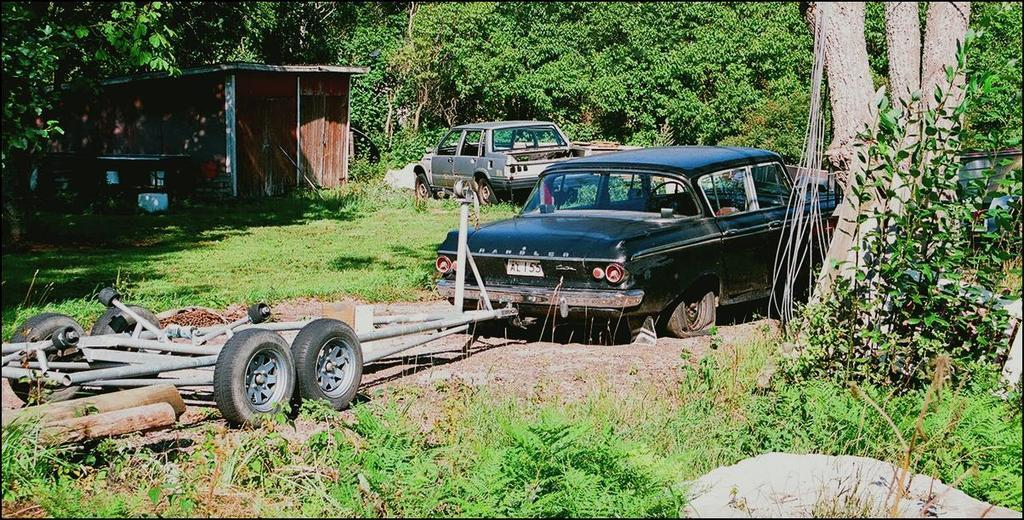What is located in the center of the image? There are vehicles in the center of the image. What type of natural elements can be seen in the image? There are trees, grass, and plants visible in the image. What objects are related to the vehicles in the image? There are tires and rods in the image. What type of structure is visible in the background of the image? There is a wooden house in the background of the image. What is the caption of the image? There is no caption present in the image. How does the income of the society depicted in the image affect the presence of the vehicles? The image does not provide any information about the society or its income, so it is not possible to determine the relationship between income and the presence of vehicles. 